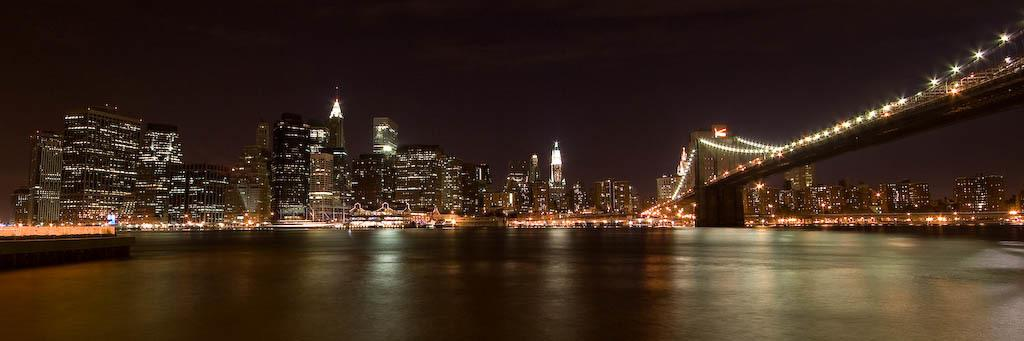What is the primary element visible in the image? There is water in the image. What can be seen in the distance behind the water? There are buildings and lights in the background of the image. What is the condition of the sky in the image? The sky is visible in the background of the image. What structure is located on the right side of the image? There is a bridge on the right side of the image. What type of question is being asked in the image? There is no question being asked in the image; it is a visual representation of water, buildings, lights, sky, and a bridge. 